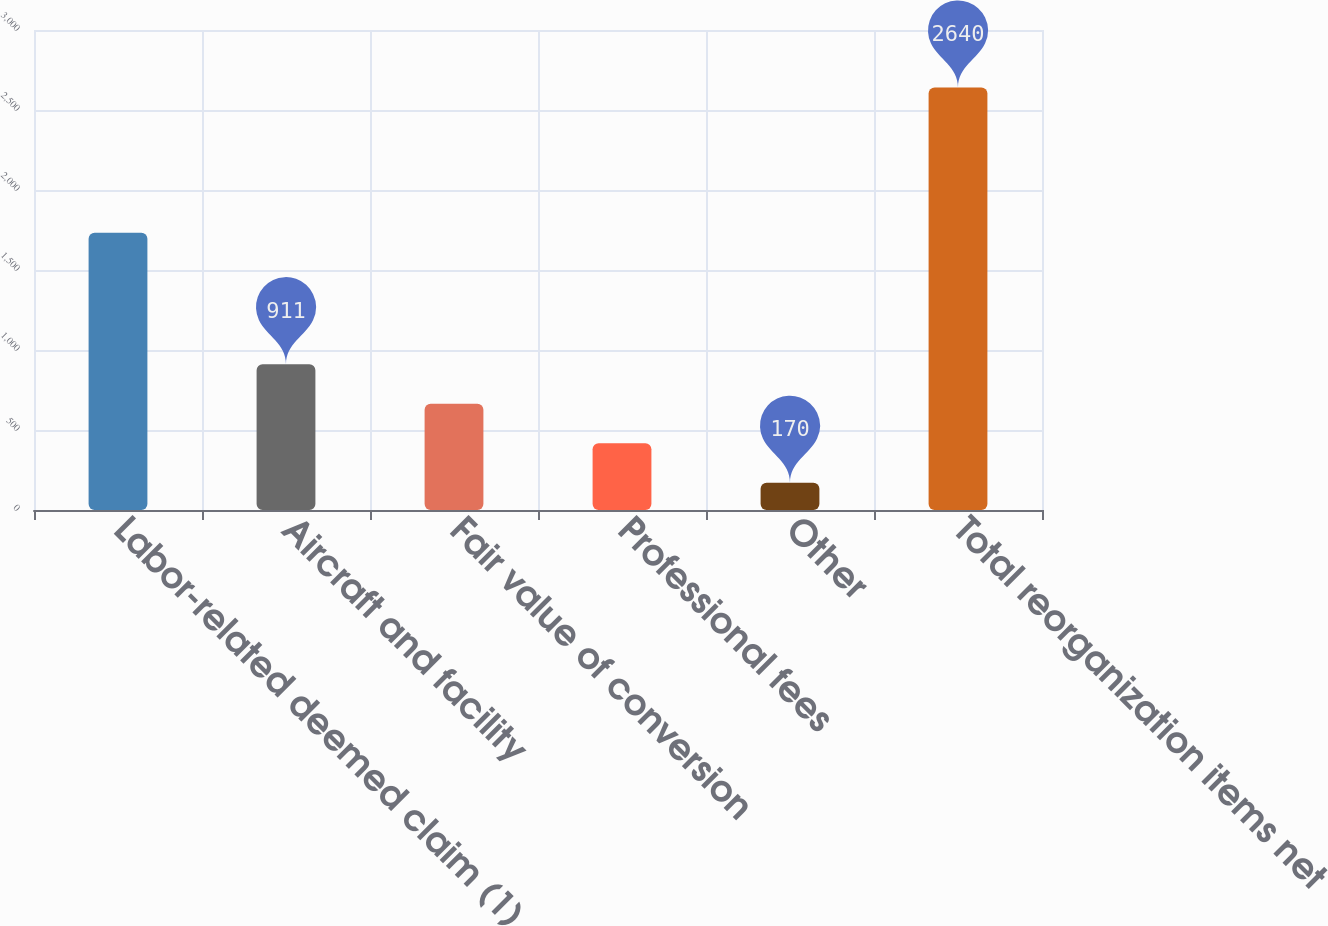<chart> <loc_0><loc_0><loc_500><loc_500><bar_chart><fcel>Labor-related deemed claim (1)<fcel>Aircraft and facility<fcel>Fair value of conversion<fcel>Professional fees<fcel>Other<fcel>Total reorganization items net<nl><fcel>1733<fcel>911<fcel>664<fcel>417<fcel>170<fcel>2640<nl></chart> 